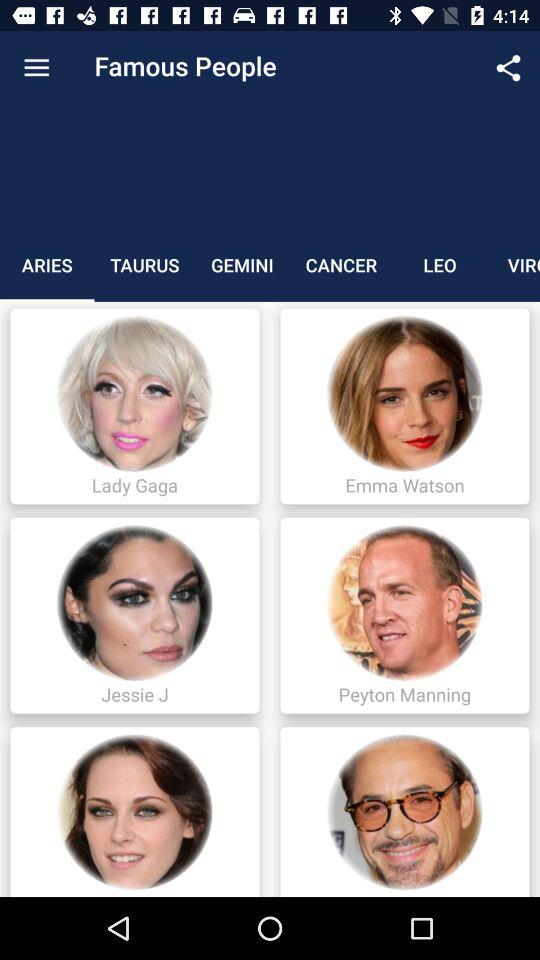Which tab am I on? You are on "ARIES" tab. 